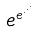<formula> <loc_0><loc_0><loc_500><loc_500>e ^ { e ^ { \cdot ^ { \cdot ^ { \cdot } } } }</formula> 